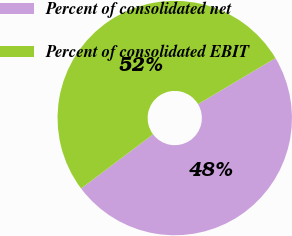<chart> <loc_0><loc_0><loc_500><loc_500><pie_chart><fcel>Percent of consolidated net<fcel>Percent of consolidated EBIT<nl><fcel>48.28%<fcel>51.72%<nl></chart> 